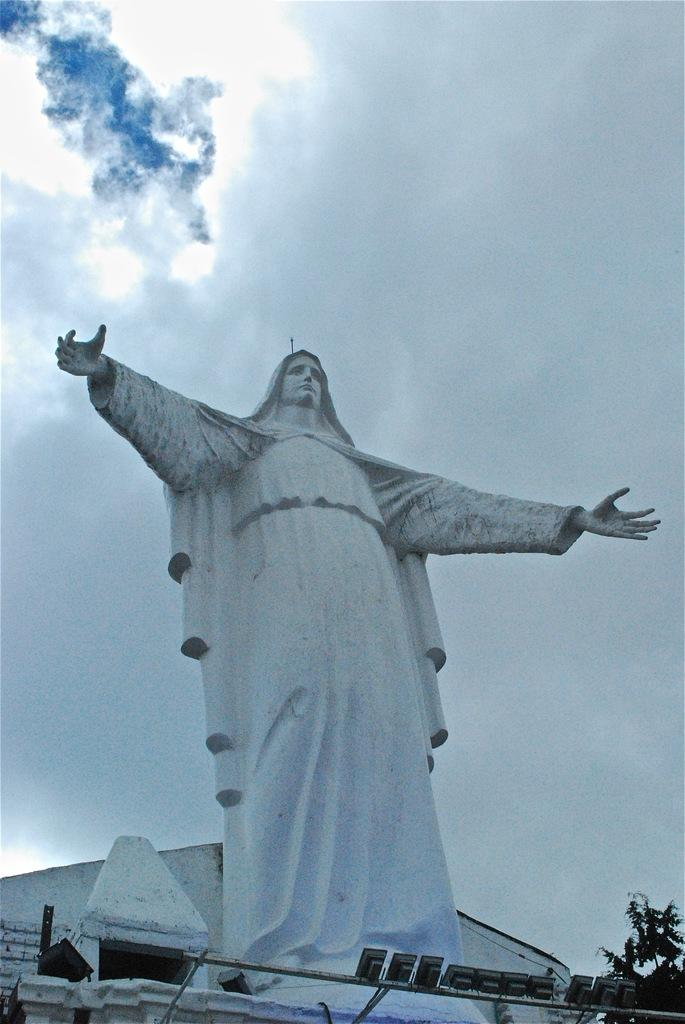What is the main subject in the center of the image? There is a sculpture in the center of the image. What can be seen on the right side of the image? There is a tree on the right side of the image. What structure is visible in the background of the image? There is a shed in the background of the image. What is visible in the background of the image besides the shed? The sky is visible in the background of the image. Can you see a cat saying good-bye to someone in the image? There is no cat or any indication of someone being bid farewell in the image. 